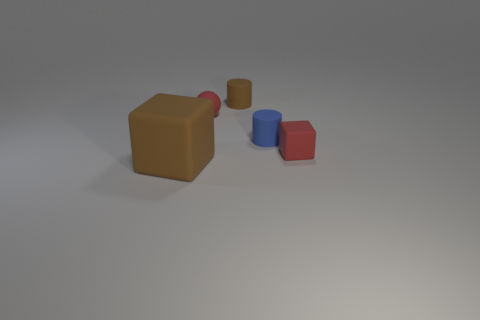Add 5 small shiny cubes. How many objects exist? 10 Subtract all cylinders. How many objects are left? 3 Subtract 0 cyan cylinders. How many objects are left? 5 Subtract 1 cubes. How many cubes are left? 1 Subtract all gray balls. Subtract all purple blocks. How many balls are left? 1 Subtract all small brown metallic cubes. Subtract all large things. How many objects are left? 4 Add 2 tiny rubber cylinders. How many tiny rubber cylinders are left? 4 Add 4 gray rubber cylinders. How many gray rubber cylinders exist? 4 